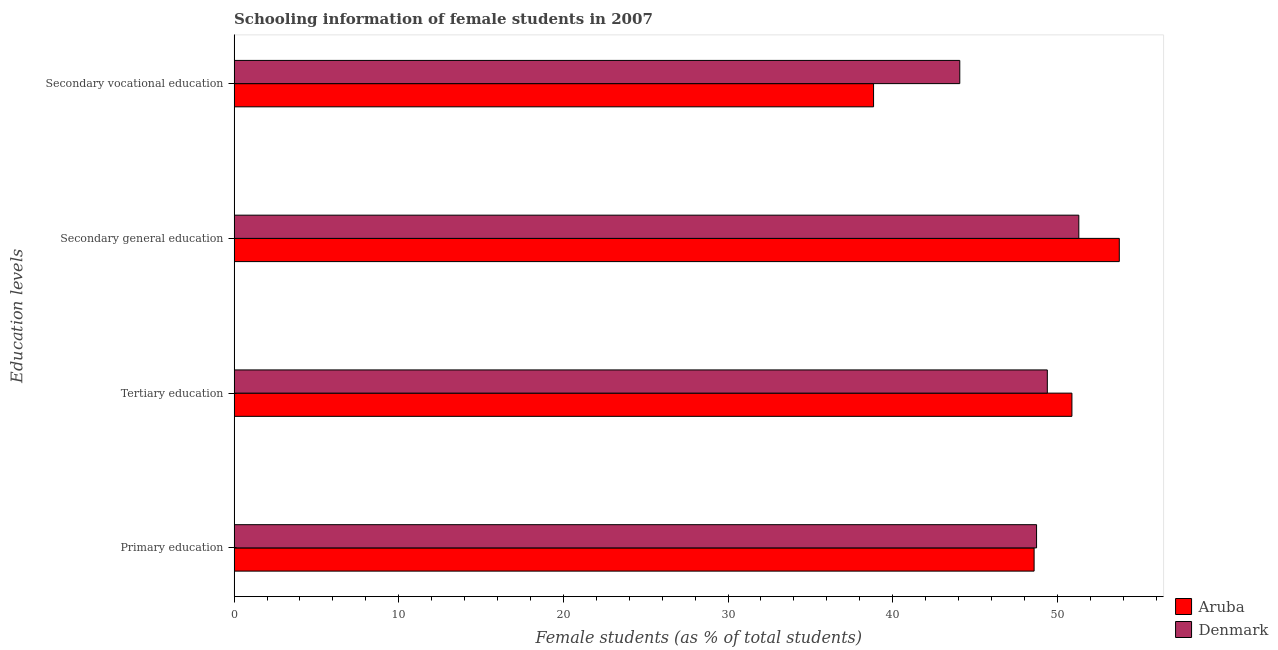How many different coloured bars are there?
Your response must be concise. 2. Are the number of bars per tick equal to the number of legend labels?
Provide a short and direct response. Yes. Are the number of bars on each tick of the Y-axis equal?
Your answer should be compact. Yes. How many bars are there on the 4th tick from the top?
Offer a terse response. 2. What is the label of the 4th group of bars from the top?
Keep it short and to the point. Primary education. What is the percentage of female students in tertiary education in Aruba?
Ensure brevity in your answer.  50.89. Across all countries, what is the maximum percentage of female students in tertiary education?
Provide a succinct answer. 50.89. Across all countries, what is the minimum percentage of female students in tertiary education?
Offer a terse response. 49.39. In which country was the percentage of female students in primary education minimum?
Your answer should be compact. Aruba. What is the total percentage of female students in tertiary education in the graph?
Keep it short and to the point. 100.28. What is the difference between the percentage of female students in secondary vocational education in Denmark and that in Aruba?
Your answer should be compact. 5.24. What is the difference between the percentage of female students in secondary vocational education in Aruba and the percentage of female students in tertiary education in Denmark?
Offer a very short reply. -10.55. What is the average percentage of female students in secondary vocational education per country?
Provide a succinct answer. 41.46. What is the difference between the percentage of female students in primary education and percentage of female students in secondary vocational education in Aruba?
Offer a terse response. 9.75. In how many countries, is the percentage of female students in tertiary education greater than 36 %?
Your answer should be compact. 2. What is the ratio of the percentage of female students in tertiary education in Denmark to that in Aruba?
Your response must be concise. 0.97. Is the percentage of female students in tertiary education in Denmark less than that in Aruba?
Make the answer very short. Yes. What is the difference between the highest and the second highest percentage of female students in tertiary education?
Provide a succinct answer. 1.49. What is the difference between the highest and the lowest percentage of female students in tertiary education?
Make the answer very short. 1.49. In how many countries, is the percentage of female students in secondary education greater than the average percentage of female students in secondary education taken over all countries?
Offer a very short reply. 1. What does the 2nd bar from the top in Secondary general education represents?
Your answer should be very brief. Aruba. Is it the case that in every country, the sum of the percentage of female students in primary education and percentage of female students in tertiary education is greater than the percentage of female students in secondary education?
Offer a terse response. Yes. Are all the bars in the graph horizontal?
Give a very brief answer. Yes. How many countries are there in the graph?
Your response must be concise. 2. What is the difference between two consecutive major ticks on the X-axis?
Your response must be concise. 10. Does the graph contain any zero values?
Make the answer very short. No. Does the graph contain grids?
Your answer should be very brief. No. How many legend labels are there?
Give a very brief answer. 2. What is the title of the graph?
Your answer should be compact. Schooling information of female students in 2007. What is the label or title of the X-axis?
Your answer should be compact. Female students (as % of total students). What is the label or title of the Y-axis?
Give a very brief answer. Education levels. What is the Female students (as % of total students) in Aruba in Primary education?
Make the answer very short. 48.59. What is the Female students (as % of total students) in Denmark in Primary education?
Ensure brevity in your answer.  48.74. What is the Female students (as % of total students) in Aruba in Tertiary education?
Keep it short and to the point. 50.89. What is the Female students (as % of total students) in Denmark in Tertiary education?
Provide a short and direct response. 49.39. What is the Female students (as % of total students) of Aruba in Secondary general education?
Provide a short and direct response. 53.76. What is the Female students (as % of total students) in Denmark in Secondary general education?
Ensure brevity in your answer.  51.3. What is the Female students (as % of total students) in Aruba in Secondary vocational education?
Your answer should be compact. 38.84. What is the Female students (as % of total students) of Denmark in Secondary vocational education?
Your answer should be very brief. 44.07. Across all Education levels, what is the maximum Female students (as % of total students) of Aruba?
Ensure brevity in your answer.  53.76. Across all Education levels, what is the maximum Female students (as % of total students) in Denmark?
Make the answer very short. 51.3. Across all Education levels, what is the minimum Female students (as % of total students) in Aruba?
Make the answer very short. 38.84. Across all Education levels, what is the minimum Female students (as % of total students) in Denmark?
Offer a very short reply. 44.07. What is the total Female students (as % of total students) in Aruba in the graph?
Offer a very short reply. 192.07. What is the total Female students (as % of total students) in Denmark in the graph?
Offer a very short reply. 193.51. What is the difference between the Female students (as % of total students) of Aruba in Primary education and that in Tertiary education?
Ensure brevity in your answer.  -2.3. What is the difference between the Female students (as % of total students) of Denmark in Primary education and that in Tertiary education?
Your answer should be very brief. -0.65. What is the difference between the Female students (as % of total students) in Aruba in Primary education and that in Secondary general education?
Your answer should be compact. -5.17. What is the difference between the Female students (as % of total students) in Denmark in Primary education and that in Secondary general education?
Provide a short and direct response. -2.57. What is the difference between the Female students (as % of total students) of Aruba in Primary education and that in Secondary vocational education?
Provide a short and direct response. 9.75. What is the difference between the Female students (as % of total students) of Denmark in Primary education and that in Secondary vocational education?
Give a very brief answer. 4.66. What is the difference between the Female students (as % of total students) of Aruba in Tertiary education and that in Secondary general education?
Offer a very short reply. -2.88. What is the difference between the Female students (as % of total students) in Denmark in Tertiary education and that in Secondary general education?
Ensure brevity in your answer.  -1.91. What is the difference between the Female students (as % of total students) of Aruba in Tertiary education and that in Secondary vocational education?
Offer a terse response. 12.05. What is the difference between the Female students (as % of total students) in Denmark in Tertiary education and that in Secondary vocational education?
Make the answer very short. 5.32. What is the difference between the Female students (as % of total students) in Aruba in Secondary general education and that in Secondary vocational education?
Ensure brevity in your answer.  14.92. What is the difference between the Female students (as % of total students) in Denmark in Secondary general education and that in Secondary vocational education?
Provide a short and direct response. 7.23. What is the difference between the Female students (as % of total students) in Aruba in Primary education and the Female students (as % of total students) in Denmark in Tertiary education?
Keep it short and to the point. -0.8. What is the difference between the Female students (as % of total students) of Aruba in Primary education and the Female students (as % of total students) of Denmark in Secondary general education?
Keep it short and to the point. -2.71. What is the difference between the Female students (as % of total students) of Aruba in Primary education and the Female students (as % of total students) of Denmark in Secondary vocational education?
Offer a terse response. 4.51. What is the difference between the Female students (as % of total students) in Aruba in Tertiary education and the Female students (as % of total students) in Denmark in Secondary general education?
Your answer should be very brief. -0.42. What is the difference between the Female students (as % of total students) of Aruba in Tertiary education and the Female students (as % of total students) of Denmark in Secondary vocational education?
Your answer should be compact. 6.81. What is the difference between the Female students (as % of total students) in Aruba in Secondary general education and the Female students (as % of total students) in Denmark in Secondary vocational education?
Your answer should be very brief. 9.69. What is the average Female students (as % of total students) of Aruba per Education levels?
Your answer should be very brief. 48.02. What is the average Female students (as % of total students) in Denmark per Education levels?
Make the answer very short. 48.38. What is the difference between the Female students (as % of total students) in Aruba and Female students (as % of total students) in Denmark in Primary education?
Your answer should be very brief. -0.15. What is the difference between the Female students (as % of total students) of Aruba and Female students (as % of total students) of Denmark in Tertiary education?
Give a very brief answer. 1.49. What is the difference between the Female students (as % of total students) of Aruba and Female students (as % of total students) of Denmark in Secondary general education?
Give a very brief answer. 2.46. What is the difference between the Female students (as % of total students) in Aruba and Female students (as % of total students) in Denmark in Secondary vocational education?
Offer a terse response. -5.24. What is the ratio of the Female students (as % of total students) in Aruba in Primary education to that in Tertiary education?
Your answer should be very brief. 0.95. What is the ratio of the Female students (as % of total students) of Denmark in Primary education to that in Tertiary education?
Provide a succinct answer. 0.99. What is the ratio of the Female students (as % of total students) in Aruba in Primary education to that in Secondary general education?
Provide a short and direct response. 0.9. What is the ratio of the Female students (as % of total students) of Denmark in Primary education to that in Secondary general education?
Your answer should be very brief. 0.95. What is the ratio of the Female students (as % of total students) of Aruba in Primary education to that in Secondary vocational education?
Offer a terse response. 1.25. What is the ratio of the Female students (as % of total students) of Denmark in Primary education to that in Secondary vocational education?
Give a very brief answer. 1.11. What is the ratio of the Female students (as % of total students) in Aruba in Tertiary education to that in Secondary general education?
Provide a succinct answer. 0.95. What is the ratio of the Female students (as % of total students) of Denmark in Tertiary education to that in Secondary general education?
Give a very brief answer. 0.96. What is the ratio of the Female students (as % of total students) in Aruba in Tertiary education to that in Secondary vocational education?
Provide a short and direct response. 1.31. What is the ratio of the Female students (as % of total students) of Denmark in Tertiary education to that in Secondary vocational education?
Your answer should be very brief. 1.12. What is the ratio of the Female students (as % of total students) in Aruba in Secondary general education to that in Secondary vocational education?
Your answer should be very brief. 1.38. What is the ratio of the Female students (as % of total students) in Denmark in Secondary general education to that in Secondary vocational education?
Offer a very short reply. 1.16. What is the difference between the highest and the second highest Female students (as % of total students) in Aruba?
Offer a terse response. 2.88. What is the difference between the highest and the second highest Female students (as % of total students) of Denmark?
Offer a very short reply. 1.91. What is the difference between the highest and the lowest Female students (as % of total students) of Aruba?
Your response must be concise. 14.92. What is the difference between the highest and the lowest Female students (as % of total students) of Denmark?
Offer a very short reply. 7.23. 